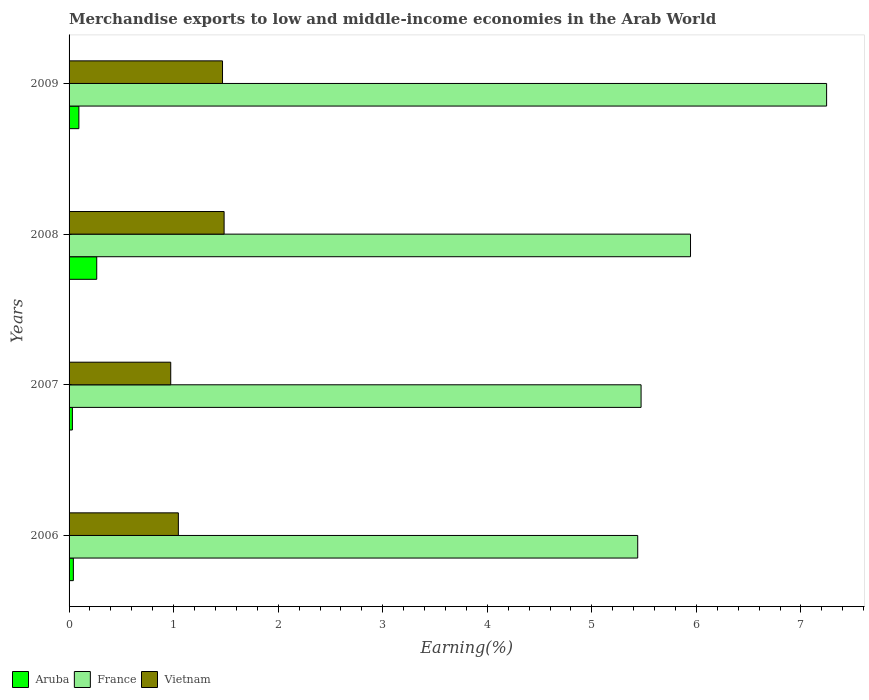How many groups of bars are there?
Provide a short and direct response. 4. Are the number of bars per tick equal to the number of legend labels?
Provide a short and direct response. Yes. Are the number of bars on each tick of the Y-axis equal?
Keep it short and to the point. Yes. How many bars are there on the 1st tick from the top?
Provide a short and direct response. 3. What is the label of the 4th group of bars from the top?
Offer a very short reply. 2006. In how many cases, is the number of bars for a given year not equal to the number of legend labels?
Keep it short and to the point. 0. What is the percentage of amount earned from merchandise exports in Vietnam in 2006?
Ensure brevity in your answer.  1.05. Across all years, what is the maximum percentage of amount earned from merchandise exports in Vietnam?
Ensure brevity in your answer.  1.48. Across all years, what is the minimum percentage of amount earned from merchandise exports in Aruba?
Provide a succinct answer. 0.03. What is the total percentage of amount earned from merchandise exports in Aruba in the graph?
Give a very brief answer. 0.43. What is the difference between the percentage of amount earned from merchandise exports in Aruba in 2007 and that in 2008?
Your answer should be very brief. -0.23. What is the difference between the percentage of amount earned from merchandise exports in Vietnam in 2008 and the percentage of amount earned from merchandise exports in France in 2007?
Your response must be concise. -3.99. What is the average percentage of amount earned from merchandise exports in Aruba per year?
Make the answer very short. 0.11. In the year 2007, what is the difference between the percentage of amount earned from merchandise exports in Aruba and percentage of amount earned from merchandise exports in France?
Ensure brevity in your answer.  -5.44. In how many years, is the percentage of amount earned from merchandise exports in Aruba greater than 4.2 %?
Keep it short and to the point. 0. What is the ratio of the percentage of amount earned from merchandise exports in Vietnam in 2006 to that in 2009?
Provide a short and direct response. 0.71. What is the difference between the highest and the second highest percentage of amount earned from merchandise exports in France?
Your answer should be very brief. 1.3. What is the difference between the highest and the lowest percentage of amount earned from merchandise exports in Vietnam?
Your answer should be compact. 0.51. Is the sum of the percentage of amount earned from merchandise exports in Aruba in 2006 and 2009 greater than the maximum percentage of amount earned from merchandise exports in Vietnam across all years?
Offer a terse response. No. What does the 2nd bar from the top in 2006 represents?
Your answer should be compact. France. What does the 2nd bar from the bottom in 2009 represents?
Provide a succinct answer. France. Are all the bars in the graph horizontal?
Your response must be concise. Yes. Are the values on the major ticks of X-axis written in scientific E-notation?
Provide a short and direct response. No. Does the graph contain any zero values?
Your answer should be compact. No. How are the legend labels stacked?
Provide a succinct answer. Horizontal. What is the title of the graph?
Your answer should be compact. Merchandise exports to low and middle-income economies in the Arab World. What is the label or title of the X-axis?
Offer a terse response. Earning(%). What is the label or title of the Y-axis?
Provide a short and direct response. Years. What is the Earning(%) in Aruba in 2006?
Ensure brevity in your answer.  0.04. What is the Earning(%) of France in 2006?
Offer a very short reply. 5.44. What is the Earning(%) of Vietnam in 2006?
Your response must be concise. 1.05. What is the Earning(%) in Aruba in 2007?
Ensure brevity in your answer.  0.03. What is the Earning(%) of France in 2007?
Your answer should be very brief. 5.47. What is the Earning(%) of Vietnam in 2007?
Make the answer very short. 0.97. What is the Earning(%) in Aruba in 2008?
Provide a short and direct response. 0.26. What is the Earning(%) of France in 2008?
Give a very brief answer. 5.94. What is the Earning(%) in Vietnam in 2008?
Keep it short and to the point. 1.48. What is the Earning(%) in Aruba in 2009?
Your answer should be compact. 0.09. What is the Earning(%) of France in 2009?
Your answer should be very brief. 7.25. What is the Earning(%) of Vietnam in 2009?
Your answer should be very brief. 1.47. Across all years, what is the maximum Earning(%) of Aruba?
Offer a very short reply. 0.26. Across all years, what is the maximum Earning(%) in France?
Give a very brief answer. 7.25. Across all years, what is the maximum Earning(%) in Vietnam?
Keep it short and to the point. 1.48. Across all years, what is the minimum Earning(%) of Aruba?
Your answer should be compact. 0.03. Across all years, what is the minimum Earning(%) in France?
Give a very brief answer. 5.44. Across all years, what is the minimum Earning(%) in Vietnam?
Provide a succinct answer. 0.97. What is the total Earning(%) in Aruba in the graph?
Offer a terse response. 0.43. What is the total Earning(%) in France in the graph?
Keep it short and to the point. 24.1. What is the total Earning(%) in Vietnam in the graph?
Your answer should be very brief. 4.97. What is the difference between the Earning(%) in Aruba in 2006 and that in 2007?
Keep it short and to the point. 0.01. What is the difference between the Earning(%) in France in 2006 and that in 2007?
Your answer should be very brief. -0.03. What is the difference between the Earning(%) in Vietnam in 2006 and that in 2007?
Provide a succinct answer. 0.07. What is the difference between the Earning(%) in Aruba in 2006 and that in 2008?
Your answer should be very brief. -0.22. What is the difference between the Earning(%) in France in 2006 and that in 2008?
Your response must be concise. -0.5. What is the difference between the Earning(%) of Vietnam in 2006 and that in 2008?
Your answer should be very brief. -0.44. What is the difference between the Earning(%) of Aruba in 2006 and that in 2009?
Offer a very short reply. -0.05. What is the difference between the Earning(%) of France in 2006 and that in 2009?
Offer a terse response. -1.81. What is the difference between the Earning(%) of Vietnam in 2006 and that in 2009?
Provide a succinct answer. -0.42. What is the difference between the Earning(%) in Aruba in 2007 and that in 2008?
Your answer should be very brief. -0.23. What is the difference between the Earning(%) of France in 2007 and that in 2008?
Your answer should be compact. -0.47. What is the difference between the Earning(%) of Vietnam in 2007 and that in 2008?
Your answer should be compact. -0.51. What is the difference between the Earning(%) of Aruba in 2007 and that in 2009?
Give a very brief answer. -0.06. What is the difference between the Earning(%) of France in 2007 and that in 2009?
Give a very brief answer. -1.77. What is the difference between the Earning(%) of Vietnam in 2007 and that in 2009?
Offer a very short reply. -0.5. What is the difference between the Earning(%) of Aruba in 2008 and that in 2009?
Keep it short and to the point. 0.17. What is the difference between the Earning(%) in France in 2008 and that in 2009?
Your answer should be compact. -1.3. What is the difference between the Earning(%) in Vietnam in 2008 and that in 2009?
Ensure brevity in your answer.  0.02. What is the difference between the Earning(%) in Aruba in 2006 and the Earning(%) in France in 2007?
Keep it short and to the point. -5.43. What is the difference between the Earning(%) of Aruba in 2006 and the Earning(%) of Vietnam in 2007?
Give a very brief answer. -0.93. What is the difference between the Earning(%) in France in 2006 and the Earning(%) in Vietnam in 2007?
Give a very brief answer. 4.47. What is the difference between the Earning(%) of Aruba in 2006 and the Earning(%) of France in 2008?
Provide a succinct answer. -5.9. What is the difference between the Earning(%) of Aruba in 2006 and the Earning(%) of Vietnam in 2008?
Offer a very short reply. -1.44. What is the difference between the Earning(%) of France in 2006 and the Earning(%) of Vietnam in 2008?
Provide a short and direct response. 3.96. What is the difference between the Earning(%) of Aruba in 2006 and the Earning(%) of France in 2009?
Keep it short and to the point. -7.2. What is the difference between the Earning(%) in Aruba in 2006 and the Earning(%) in Vietnam in 2009?
Provide a short and direct response. -1.43. What is the difference between the Earning(%) in France in 2006 and the Earning(%) in Vietnam in 2009?
Provide a succinct answer. 3.97. What is the difference between the Earning(%) in Aruba in 2007 and the Earning(%) in France in 2008?
Your answer should be compact. -5.91. What is the difference between the Earning(%) of Aruba in 2007 and the Earning(%) of Vietnam in 2008?
Offer a very short reply. -1.45. What is the difference between the Earning(%) in France in 2007 and the Earning(%) in Vietnam in 2008?
Offer a terse response. 3.99. What is the difference between the Earning(%) in Aruba in 2007 and the Earning(%) in France in 2009?
Your answer should be very brief. -7.21. What is the difference between the Earning(%) of Aruba in 2007 and the Earning(%) of Vietnam in 2009?
Provide a succinct answer. -1.44. What is the difference between the Earning(%) in France in 2007 and the Earning(%) in Vietnam in 2009?
Provide a succinct answer. 4. What is the difference between the Earning(%) of Aruba in 2008 and the Earning(%) of France in 2009?
Offer a terse response. -6.98. What is the difference between the Earning(%) in Aruba in 2008 and the Earning(%) in Vietnam in 2009?
Make the answer very short. -1.2. What is the difference between the Earning(%) of France in 2008 and the Earning(%) of Vietnam in 2009?
Provide a succinct answer. 4.48. What is the average Earning(%) of Aruba per year?
Offer a terse response. 0.11. What is the average Earning(%) of France per year?
Provide a short and direct response. 6.02. What is the average Earning(%) in Vietnam per year?
Offer a terse response. 1.24. In the year 2006, what is the difference between the Earning(%) of Aruba and Earning(%) of France?
Ensure brevity in your answer.  -5.4. In the year 2006, what is the difference between the Earning(%) of Aruba and Earning(%) of Vietnam?
Provide a succinct answer. -1. In the year 2006, what is the difference between the Earning(%) of France and Earning(%) of Vietnam?
Your answer should be very brief. 4.39. In the year 2007, what is the difference between the Earning(%) in Aruba and Earning(%) in France?
Keep it short and to the point. -5.44. In the year 2007, what is the difference between the Earning(%) in Aruba and Earning(%) in Vietnam?
Offer a very short reply. -0.94. In the year 2007, what is the difference between the Earning(%) in France and Earning(%) in Vietnam?
Your answer should be compact. 4.5. In the year 2008, what is the difference between the Earning(%) of Aruba and Earning(%) of France?
Provide a succinct answer. -5.68. In the year 2008, what is the difference between the Earning(%) of Aruba and Earning(%) of Vietnam?
Your answer should be compact. -1.22. In the year 2008, what is the difference between the Earning(%) in France and Earning(%) in Vietnam?
Ensure brevity in your answer.  4.46. In the year 2009, what is the difference between the Earning(%) in Aruba and Earning(%) in France?
Offer a very short reply. -7.15. In the year 2009, what is the difference between the Earning(%) in Aruba and Earning(%) in Vietnam?
Provide a short and direct response. -1.37. In the year 2009, what is the difference between the Earning(%) in France and Earning(%) in Vietnam?
Keep it short and to the point. 5.78. What is the ratio of the Earning(%) of Aruba in 2006 to that in 2007?
Make the answer very short. 1.29. What is the ratio of the Earning(%) of Vietnam in 2006 to that in 2007?
Provide a succinct answer. 1.07. What is the ratio of the Earning(%) in Aruba in 2006 to that in 2008?
Ensure brevity in your answer.  0.16. What is the ratio of the Earning(%) in France in 2006 to that in 2008?
Make the answer very short. 0.92. What is the ratio of the Earning(%) of Vietnam in 2006 to that in 2008?
Keep it short and to the point. 0.7. What is the ratio of the Earning(%) in Aruba in 2006 to that in 2009?
Make the answer very short. 0.44. What is the ratio of the Earning(%) of France in 2006 to that in 2009?
Your response must be concise. 0.75. What is the ratio of the Earning(%) in Vietnam in 2006 to that in 2009?
Give a very brief answer. 0.71. What is the ratio of the Earning(%) of Aruba in 2007 to that in 2008?
Ensure brevity in your answer.  0.12. What is the ratio of the Earning(%) in France in 2007 to that in 2008?
Keep it short and to the point. 0.92. What is the ratio of the Earning(%) in Vietnam in 2007 to that in 2008?
Your response must be concise. 0.66. What is the ratio of the Earning(%) in Aruba in 2007 to that in 2009?
Offer a very short reply. 0.34. What is the ratio of the Earning(%) in France in 2007 to that in 2009?
Give a very brief answer. 0.76. What is the ratio of the Earning(%) in Vietnam in 2007 to that in 2009?
Provide a short and direct response. 0.66. What is the ratio of the Earning(%) in Aruba in 2008 to that in 2009?
Your answer should be very brief. 2.82. What is the ratio of the Earning(%) in France in 2008 to that in 2009?
Your answer should be very brief. 0.82. What is the ratio of the Earning(%) of Vietnam in 2008 to that in 2009?
Your answer should be very brief. 1.01. What is the difference between the highest and the second highest Earning(%) in Aruba?
Give a very brief answer. 0.17. What is the difference between the highest and the second highest Earning(%) of France?
Provide a succinct answer. 1.3. What is the difference between the highest and the second highest Earning(%) in Vietnam?
Ensure brevity in your answer.  0.02. What is the difference between the highest and the lowest Earning(%) in Aruba?
Make the answer very short. 0.23. What is the difference between the highest and the lowest Earning(%) in France?
Give a very brief answer. 1.81. What is the difference between the highest and the lowest Earning(%) in Vietnam?
Your response must be concise. 0.51. 